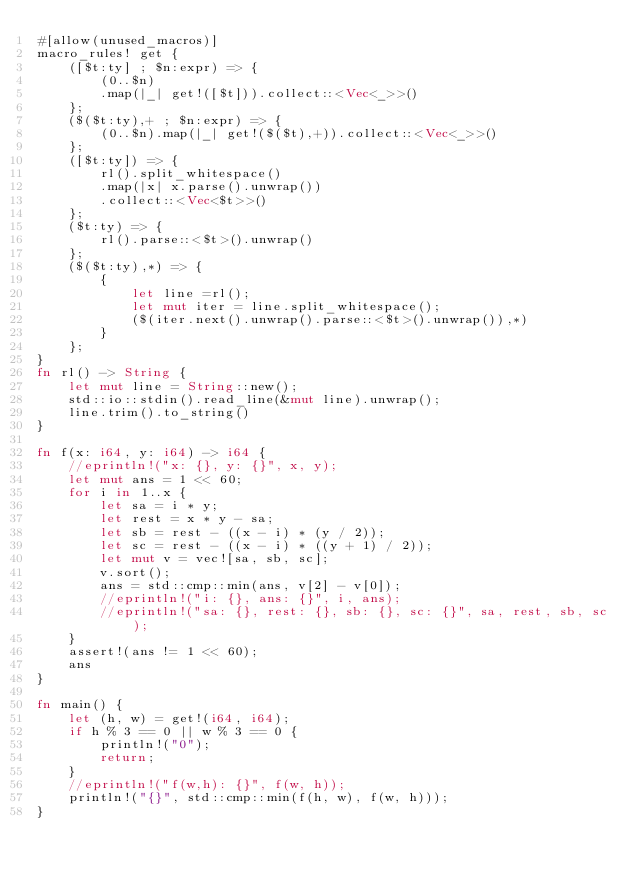<code> <loc_0><loc_0><loc_500><loc_500><_Rust_>#[allow(unused_macros)]
macro_rules! get {
    ([$t:ty] ; $n:expr) => {
        (0..$n)
        .map(|_| get!([$t])).collect::<Vec<_>>()
    };
    ($($t:ty),+ ; $n:expr) => {
        (0..$n).map(|_| get!($($t),+)).collect::<Vec<_>>()
    };
    ([$t:ty]) => {
        rl().split_whitespace()
        .map(|x| x.parse().unwrap())
        .collect::<Vec<$t>>()
    };
    ($t:ty) => {
        rl().parse::<$t>().unwrap()
    };
    ($($t:ty),*) => {
        {
            let line =rl();
            let mut iter = line.split_whitespace();
            ($(iter.next().unwrap().parse::<$t>().unwrap()),*)
        }
    };
}
fn rl() -> String {
    let mut line = String::new();
    std::io::stdin().read_line(&mut line).unwrap();
    line.trim().to_string()
}

fn f(x: i64, y: i64) -> i64 {
    //eprintln!("x: {}, y: {}", x, y);
    let mut ans = 1 << 60;
    for i in 1..x {
        let sa = i * y;
        let rest = x * y - sa;
        let sb = rest - ((x - i) * (y / 2));
        let sc = rest - ((x - i) * ((y + 1) / 2));
        let mut v = vec![sa, sb, sc];
        v.sort();
        ans = std::cmp::min(ans, v[2] - v[0]);
        //eprintln!("i: {}, ans: {}", i, ans);
        //eprintln!("sa: {}, rest: {}, sb: {}, sc: {}", sa, rest, sb, sc);
    }
    assert!(ans != 1 << 60);
    ans
}

fn main() {
    let (h, w) = get!(i64, i64);
    if h % 3 == 0 || w % 3 == 0 {
        println!("0");
        return;
    }
    //eprintln!("f(w,h): {}", f(w, h));
    println!("{}", std::cmp::min(f(h, w), f(w, h)));
}
</code> 